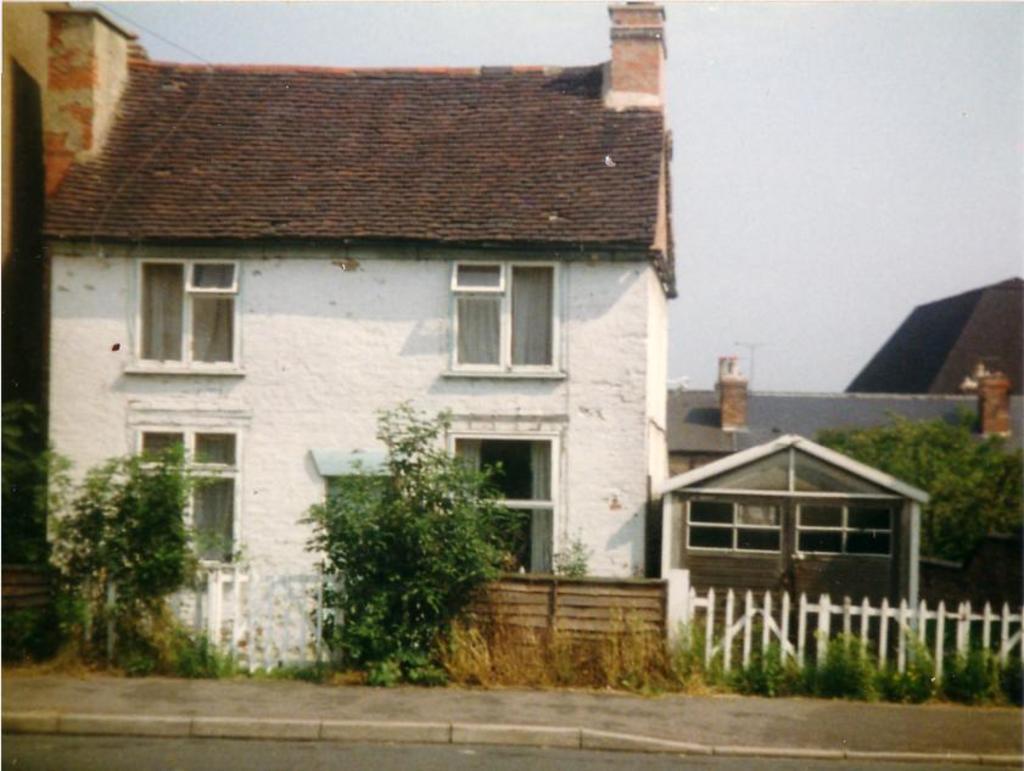Describe this image in one or two sentences. In this image we can see buildings with windows and roofs. In the foreground we can see a fence, a group of trees. In the background we can see the sky. 